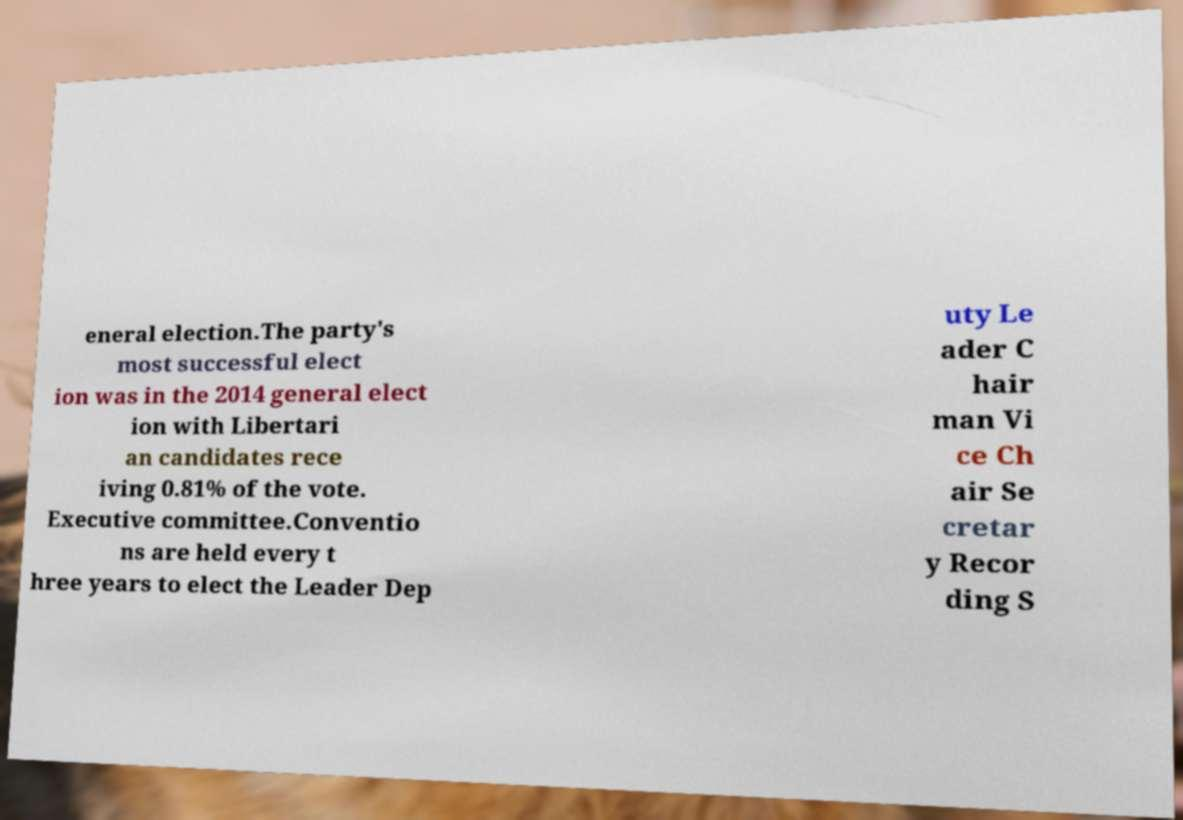Please identify and transcribe the text found in this image. eneral election.The party's most successful elect ion was in the 2014 general elect ion with Libertari an candidates rece iving 0.81% of the vote. Executive committee.Conventio ns are held every t hree years to elect the Leader Dep uty Le ader C hair man Vi ce Ch air Se cretar y Recor ding S 